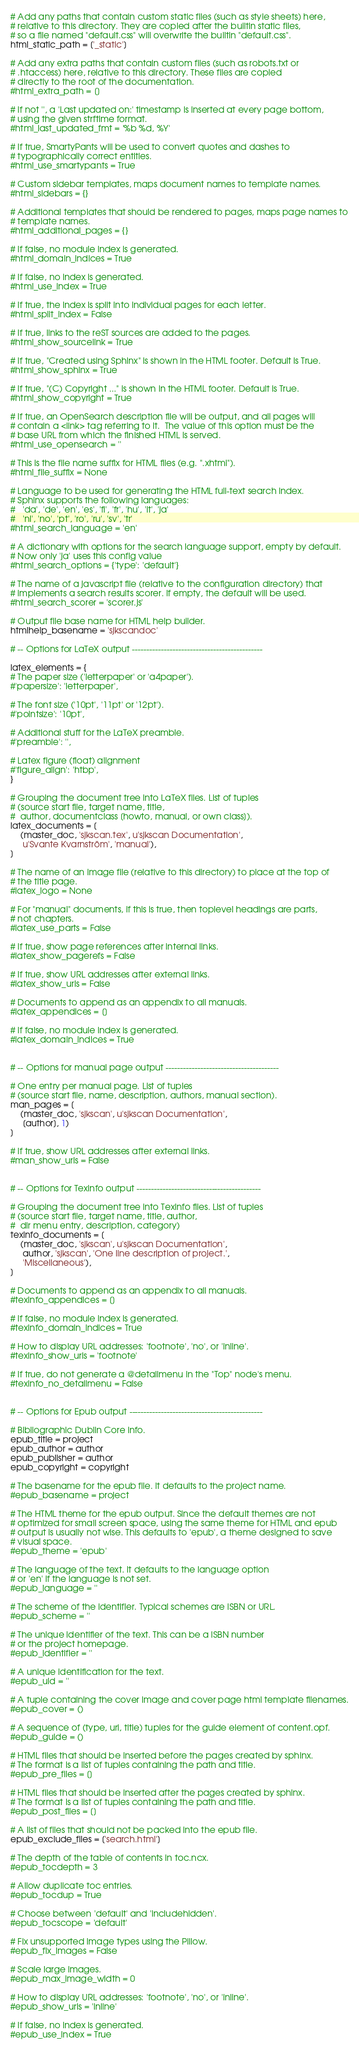Convert code to text. <code><loc_0><loc_0><loc_500><loc_500><_Python_># Add any paths that contain custom static files (such as style sheets) here,
# relative to this directory. They are copied after the builtin static files,
# so a file named "default.css" will overwrite the builtin "default.css".
html_static_path = ['_static']

# Add any extra paths that contain custom files (such as robots.txt or
# .htaccess) here, relative to this directory. These files are copied
# directly to the root of the documentation.
#html_extra_path = []

# If not '', a 'Last updated on:' timestamp is inserted at every page bottom,
# using the given strftime format.
#html_last_updated_fmt = '%b %d, %Y'

# If true, SmartyPants will be used to convert quotes and dashes to
# typographically correct entities.
#html_use_smartypants = True

# Custom sidebar templates, maps document names to template names.
#html_sidebars = {}

# Additional templates that should be rendered to pages, maps page names to
# template names.
#html_additional_pages = {}

# If false, no module index is generated.
#html_domain_indices = True

# If false, no index is generated.
#html_use_index = True

# If true, the index is split into individual pages for each letter.
#html_split_index = False

# If true, links to the reST sources are added to the pages.
#html_show_sourcelink = True

# If true, "Created using Sphinx" is shown in the HTML footer. Default is True.
#html_show_sphinx = True

# If true, "(C) Copyright ..." is shown in the HTML footer. Default is True.
#html_show_copyright = True

# If true, an OpenSearch description file will be output, and all pages will
# contain a <link> tag referring to it.  The value of this option must be the
# base URL from which the finished HTML is served.
#html_use_opensearch = ''

# This is the file name suffix for HTML files (e.g. ".xhtml").
#html_file_suffix = None

# Language to be used for generating the HTML full-text search index.
# Sphinx supports the following languages:
#   'da', 'de', 'en', 'es', 'fi', 'fr', 'hu', 'it', 'ja'
#   'nl', 'no', 'pt', 'ro', 'ru', 'sv', 'tr'
#html_search_language = 'en'

# A dictionary with options for the search language support, empty by default.
# Now only 'ja' uses this config value
#html_search_options = {'type': 'default'}

# The name of a javascript file (relative to the configuration directory) that
# implements a search results scorer. If empty, the default will be used.
#html_search_scorer = 'scorer.js'

# Output file base name for HTML help builder.
htmlhelp_basename = 'sjkscandoc'

# -- Options for LaTeX output ---------------------------------------------

latex_elements = {
# The paper size ('letterpaper' or 'a4paper').
#'papersize': 'letterpaper',

# The font size ('10pt', '11pt' or '12pt').
#'pointsize': '10pt',

# Additional stuff for the LaTeX preamble.
#'preamble': '',

# Latex figure (float) alignment
#'figure_align': 'htbp',
}

# Grouping the document tree into LaTeX files. List of tuples
# (source start file, target name, title,
#  author, documentclass [howto, manual, or own class]).
latex_documents = [
    (master_doc, 'sjkscan.tex', u'sjkscan Documentation',
     u'Svante Kvarnström', 'manual'),
]

# The name of an image file (relative to this directory) to place at the top of
# the title page.
#latex_logo = None

# For "manual" documents, if this is true, then toplevel headings are parts,
# not chapters.
#latex_use_parts = False

# If true, show page references after internal links.
#latex_show_pagerefs = False

# If true, show URL addresses after external links.
#latex_show_urls = False

# Documents to append as an appendix to all manuals.
#latex_appendices = []

# If false, no module index is generated.
#latex_domain_indices = True


# -- Options for manual page output ---------------------------------------

# One entry per manual page. List of tuples
# (source start file, name, description, authors, manual section).
man_pages = [
    (master_doc, 'sjkscan', u'sjkscan Documentation',
     [author], 1)
]

# If true, show URL addresses after external links.
#man_show_urls = False


# -- Options for Texinfo output -------------------------------------------

# Grouping the document tree into Texinfo files. List of tuples
# (source start file, target name, title, author,
#  dir menu entry, description, category)
texinfo_documents = [
    (master_doc, 'sjkscan', u'sjkscan Documentation',
     author, 'sjkscan', 'One line description of project.',
     'Miscellaneous'),
]

# Documents to append as an appendix to all manuals.
#texinfo_appendices = []

# If false, no module index is generated.
#texinfo_domain_indices = True

# How to display URL addresses: 'footnote', 'no', or 'inline'.
#texinfo_show_urls = 'footnote'

# If true, do not generate a @detailmenu in the "Top" node's menu.
#texinfo_no_detailmenu = False


# -- Options for Epub output ----------------------------------------------

# Bibliographic Dublin Core info.
epub_title = project
epub_author = author
epub_publisher = author
epub_copyright = copyright

# The basename for the epub file. It defaults to the project name.
#epub_basename = project

# The HTML theme for the epub output. Since the default themes are not
# optimized for small screen space, using the same theme for HTML and epub
# output is usually not wise. This defaults to 'epub', a theme designed to save
# visual space.
#epub_theme = 'epub'

# The language of the text. It defaults to the language option
# or 'en' if the language is not set.
#epub_language = ''

# The scheme of the identifier. Typical schemes are ISBN or URL.
#epub_scheme = ''

# The unique identifier of the text. This can be a ISBN number
# or the project homepage.
#epub_identifier = ''

# A unique identification for the text.
#epub_uid = ''

# A tuple containing the cover image and cover page html template filenames.
#epub_cover = ()

# A sequence of (type, uri, title) tuples for the guide element of content.opf.
#epub_guide = ()

# HTML files that should be inserted before the pages created by sphinx.
# The format is a list of tuples containing the path and title.
#epub_pre_files = []

# HTML files that should be inserted after the pages created by sphinx.
# The format is a list of tuples containing the path and title.
#epub_post_files = []

# A list of files that should not be packed into the epub file.
epub_exclude_files = ['search.html']

# The depth of the table of contents in toc.ncx.
#epub_tocdepth = 3

# Allow duplicate toc entries.
#epub_tocdup = True

# Choose between 'default' and 'includehidden'.
#epub_tocscope = 'default'

# Fix unsupported image types using the Pillow.
#epub_fix_images = False

# Scale large images.
#epub_max_image_width = 0

# How to display URL addresses: 'footnote', 'no', or 'inline'.
#epub_show_urls = 'inline'

# If false, no index is generated.
#epub_use_index = True
</code> 